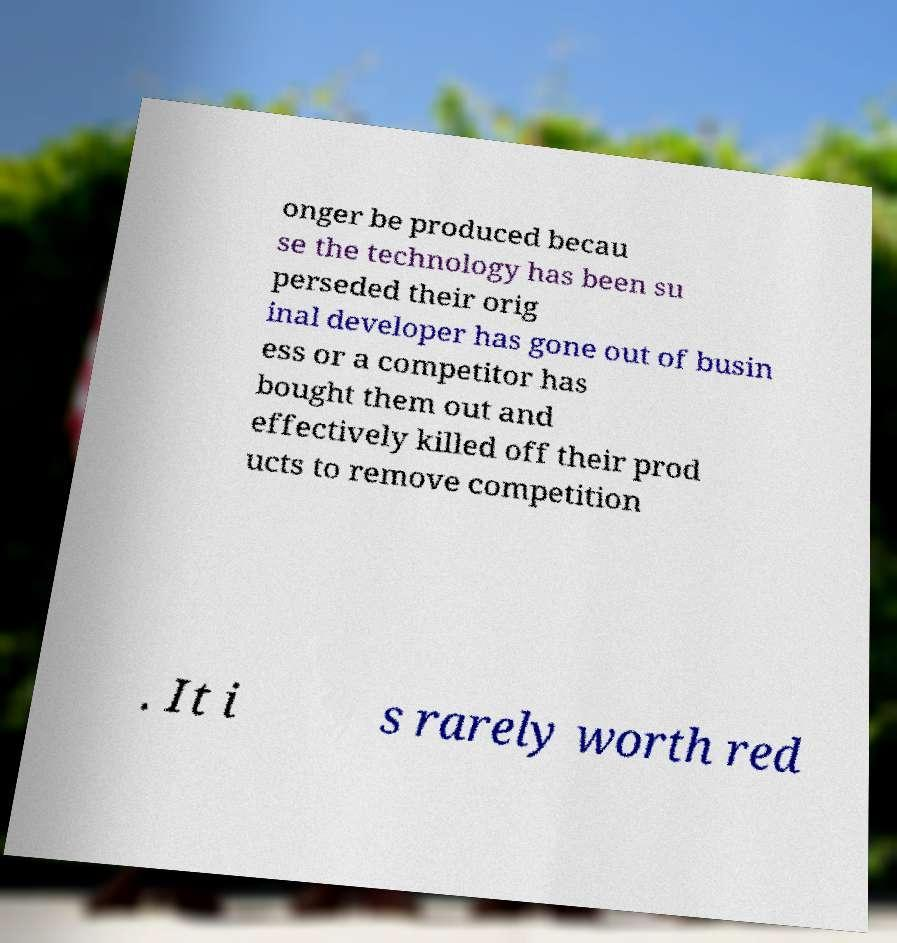Could you assist in decoding the text presented in this image and type it out clearly? onger be produced becau se the technology has been su perseded their orig inal developer has gone out of busin ess or a competitor has bought them out and effectively killed off their prod ucts to remove competition . It i s rarely worth red 